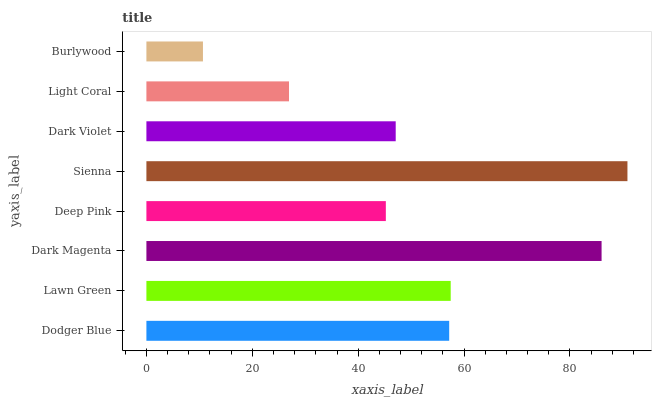Is Burlywood the minimum?
Answer yes or no. Yes. Is Sienna the maximum?
Answer yes or no. Yes. Is Lawn Green the minimum?
Answer yes or no. No. Is Lawn Green the maximum?
Answer yes or no. No. Is Lawn Green greater than Dodger Blue?
Answer yes or no. Yes. Is Dodger Blue less than Lawn Green?
Answer yes or no. Yes. Is Dodger Blue greater than Lawn Green?
Answer yes or no. No. Is Lawn Green less than Dodger Blue?
Answer yes or no. No. Is Dodger Blue the high median?
Answer yes or no. Yes. Is Dark Violet the low median?
Answer yes or no. Yes. Is Lawn Green the high median?
Answer yes or no. No. Is Lawn Green the low median?
Answer yes or no. No. 